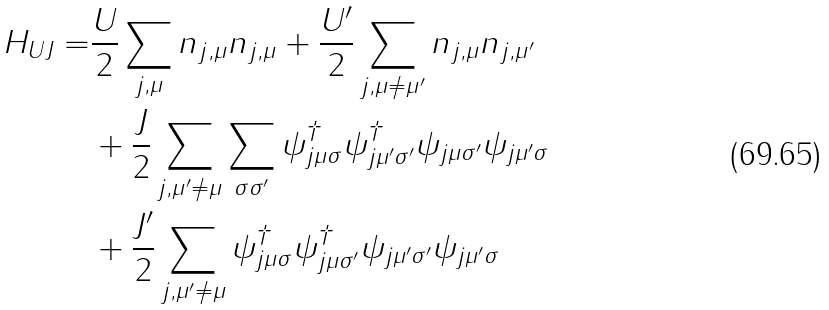Convert formula to latex. <formula><loc_0><loc_0><loc_500><loc_500>H _ { U J } = & \frac { U } { 2 } \sum _ { j , \mu } n _ { j , \mu } n _ { j , \mu } + \frac { U ^ { \prime } } { 2 } \sum _ { j , \mu \neq \mu ^ { \prime } } n _ { j , \mu } n _ { j , \mu ^ { \prime } } \\ & + \frac { J } { 2 } \sum _ { j , \mu ^ { \prime } \neq \mu } \sum _ { \sigma \sigma ^ { \prime } } \psi _ { j \mu \sigma } ^ { \dag } \psi _ { j \mu ^ { \prime } \sigma ^ { \prime } } ^ { \dag } \psi _ { j \mu \sigma ^ { \prime } } \psi _ { j \mu ^ { \prime } \sigma } \\ & + \frac { J ^ { \prime } } { 2 } \sum _ { j , \mu ^ { \prime } \neq \mu } \psi _ { j \mu \sigma } ^ { \dag } \psi _ { j \mu \sigma ^ { \prime } } ^ { \dag } \psi _ { j \mu ^ { \prime } \sigma ^ { \prime } } \psi _ { j \mu ^ { \prime } \sigma } \,</formula> 